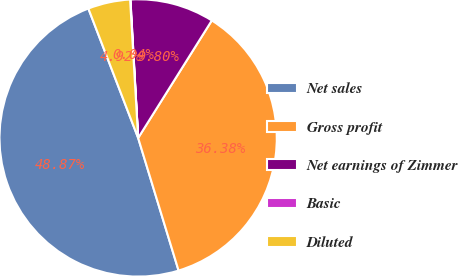Convert chart to OTSL. <chart><loc_0><loc_0><loc_500><loc_500><pie_chart><fcel>Net sales<fcel>Gross profit<fcel>Net earnings of Zimmer<fcel>Basic<fcel>Diluted<nl><fcel>48.87%<fcel>36.38%<fcel>9.8%<fcel>0.04%<fcel>4.92%<nl></chart> 